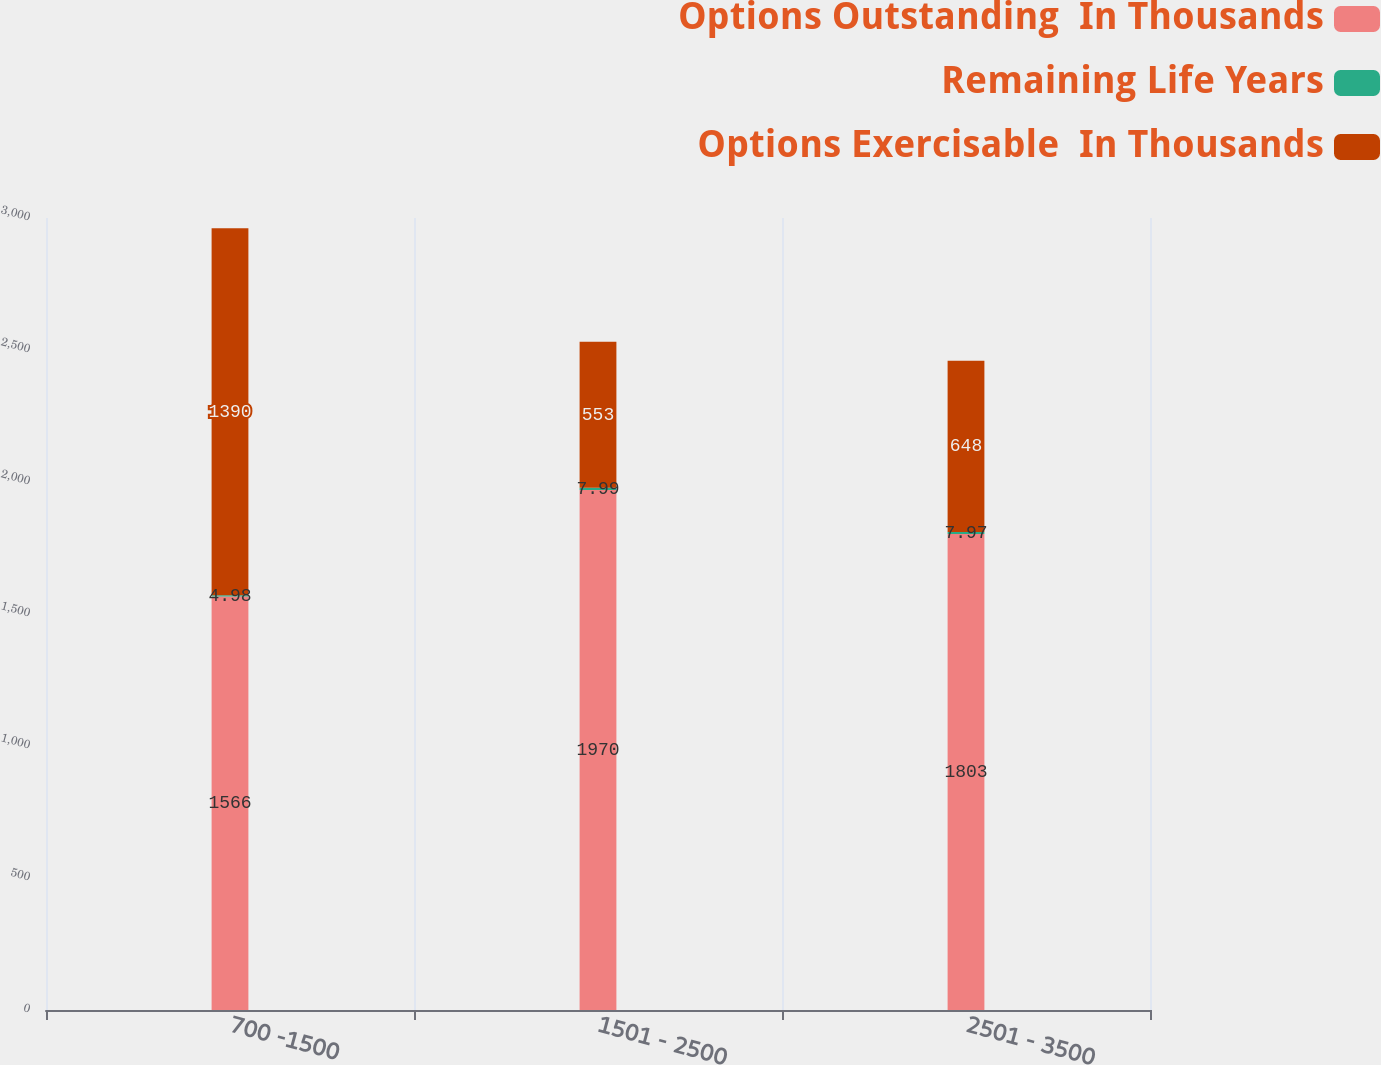Convert chart to OTSL. <chart><loc_0><loc_0><loc_500><loc_500><stacked_bar_chart><ecel><fcel>700 -1500<fcel>1501 - 2500<fcel>2501 - 3500<nl><fcel>Options Outstanding  In Thousands<fcel>1566<fcel>1970<fcel>1803<nl><fcel>Remaining Life Years<fcel>4.98<fcel>7.99<fcel>7.97<nl><fcel>Options Exercisable  In Thousands<fcel>1390<fcel>553<fcel>648<nl></chart> 